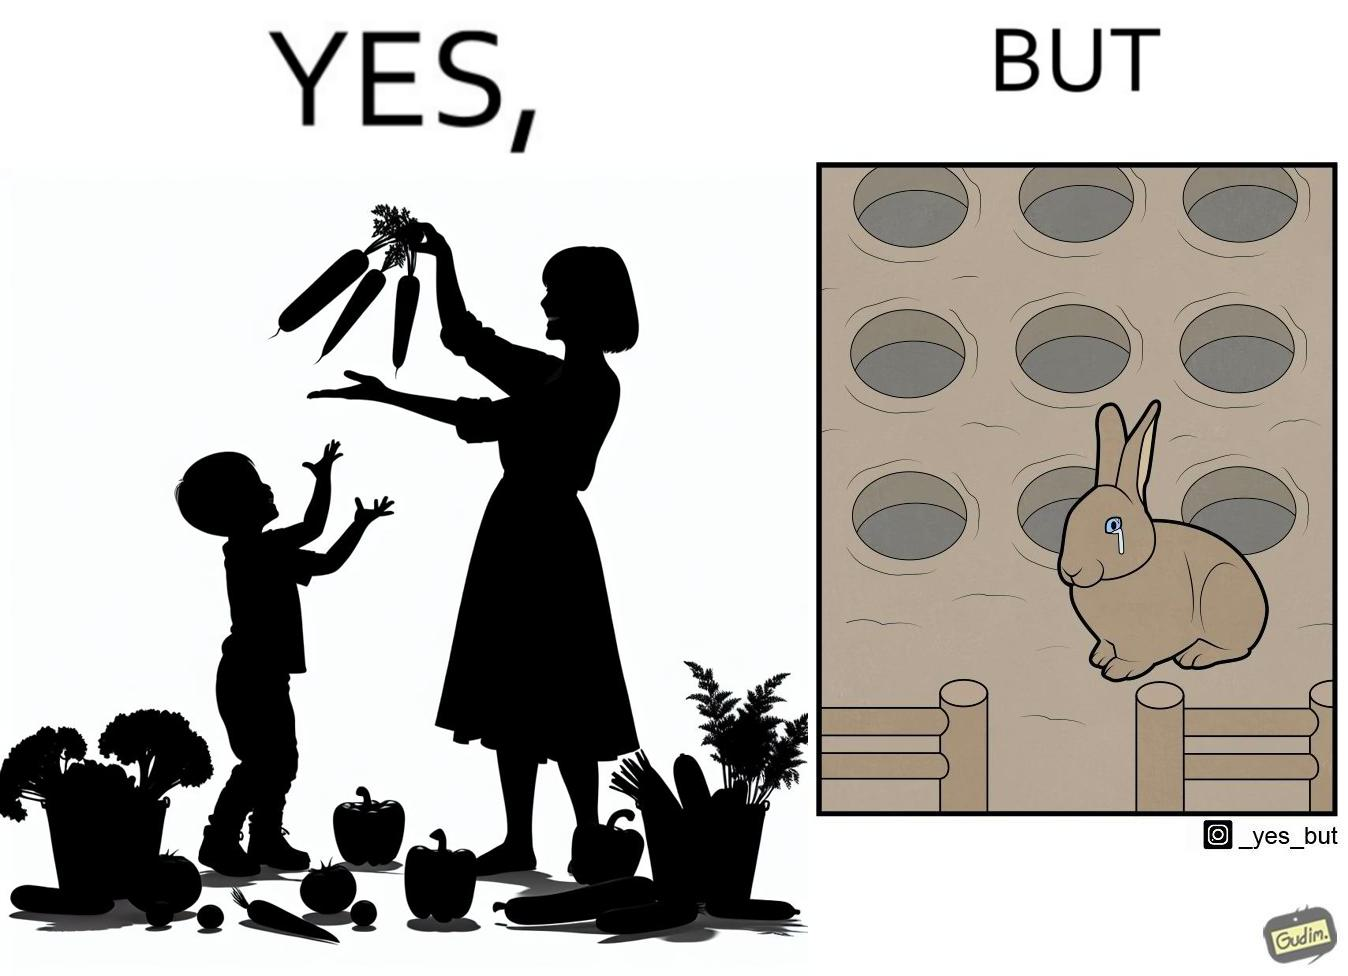Describe the contrast between the left and right parts of this image. In the left part of the image: It is a woman and child making funny shapes with vegetables and playing with them In the right part of the image: It is rabbit crying in a ground full of holes 